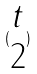<formula> <loc_0><loc_0><loc_500><loc_500>( \begin{matrix} t \\ 2 \end{matrix} )</formula> 